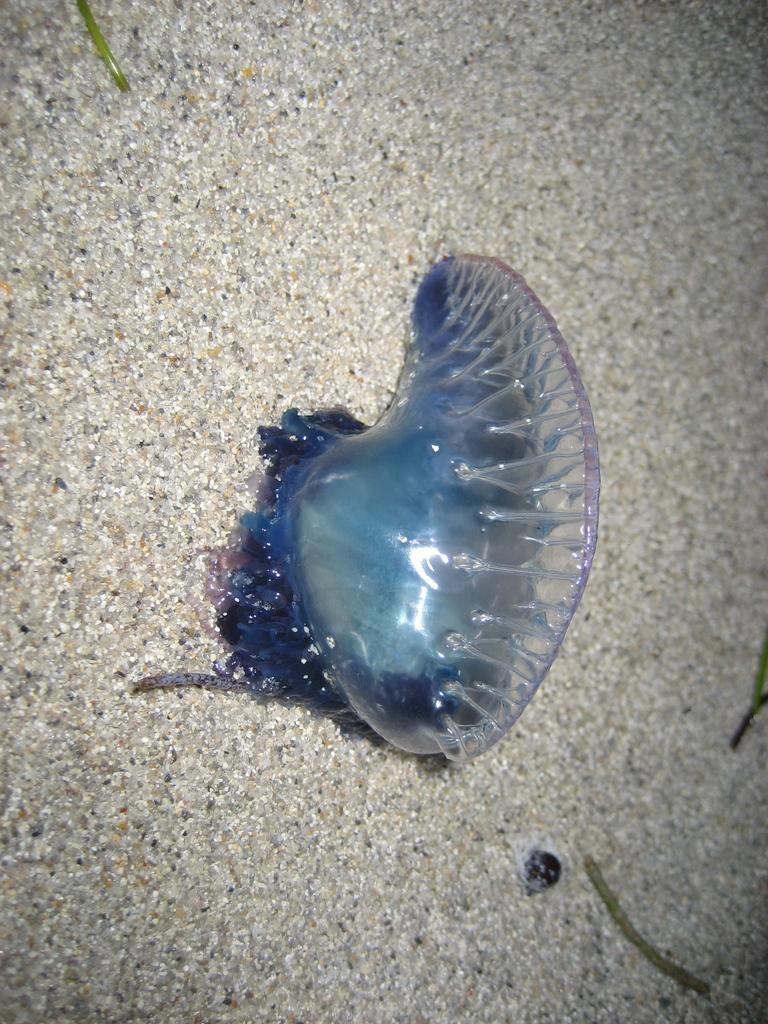What type of creatures can be seen on the floor in the image? There are insects on the floor in the image. What else is present in the image besides the insects? There are small green sticks in the image. What type of bird can be seen flying in the image? There is no bird present in the image; it only features insects and small green sticks. 